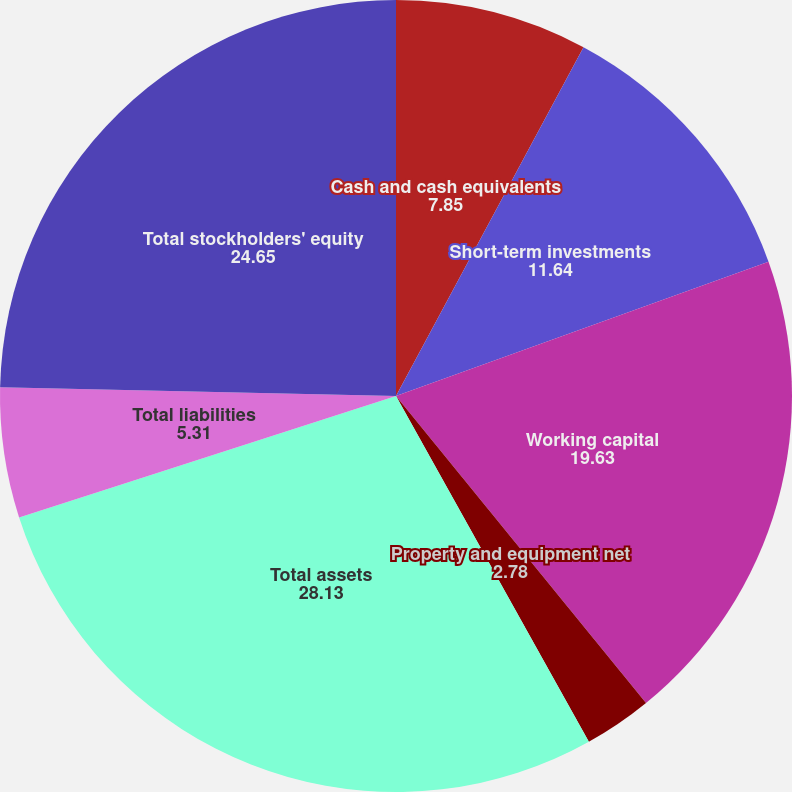Convert chart. <chart><loc_0><loc_0><loc_500><loc_500><pie_chart><fcel>Cash and cash equivalents<fcel>Short-term investments<fcel>Working capital<fcel>Property and equipment net<fcel>Total assets<fcel>Total liabilities<fcel>Total stockholders' equity<nl><fcel>7.85%<fcel>11.64%<fcel>19.63%<fcel>2.78%<fcel>28.13%<fcel>5.31%<fcel>24.65%<nl></chart> 